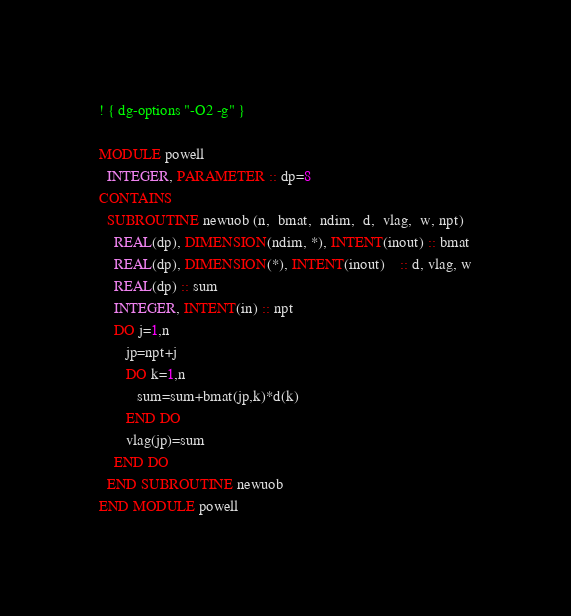<code> <loc_0><loc_0><loc_500><loc_500><_FORTRAN_>! { dg-options "-O2 -g" }

MODULE powell
  INTEGER, PARAMETER :: dp=8
CONTAINS
  SUBROUTINE newuob (n,  bmat,  ndim,  d,  vlag,  w, npt)
    REAL(dp), DIMENSION(ndim, *), INTENT(inout) :: bmat
    REAL(dp), DIMENSION(*), INTENT(inout)    :: d, vlag, w
    REAL(dp) :: sum
    INTEGER, INTENT(in) :: npt
    DO j=1,n
       jp=npt+j
       DO k=1,n
          sum=sum+bmat(jp,k)*d(k)
       END DO
       vlag(jp)=sum
    END DO
  END SUBROUTINE newuob
END MODULE powell
</code> 